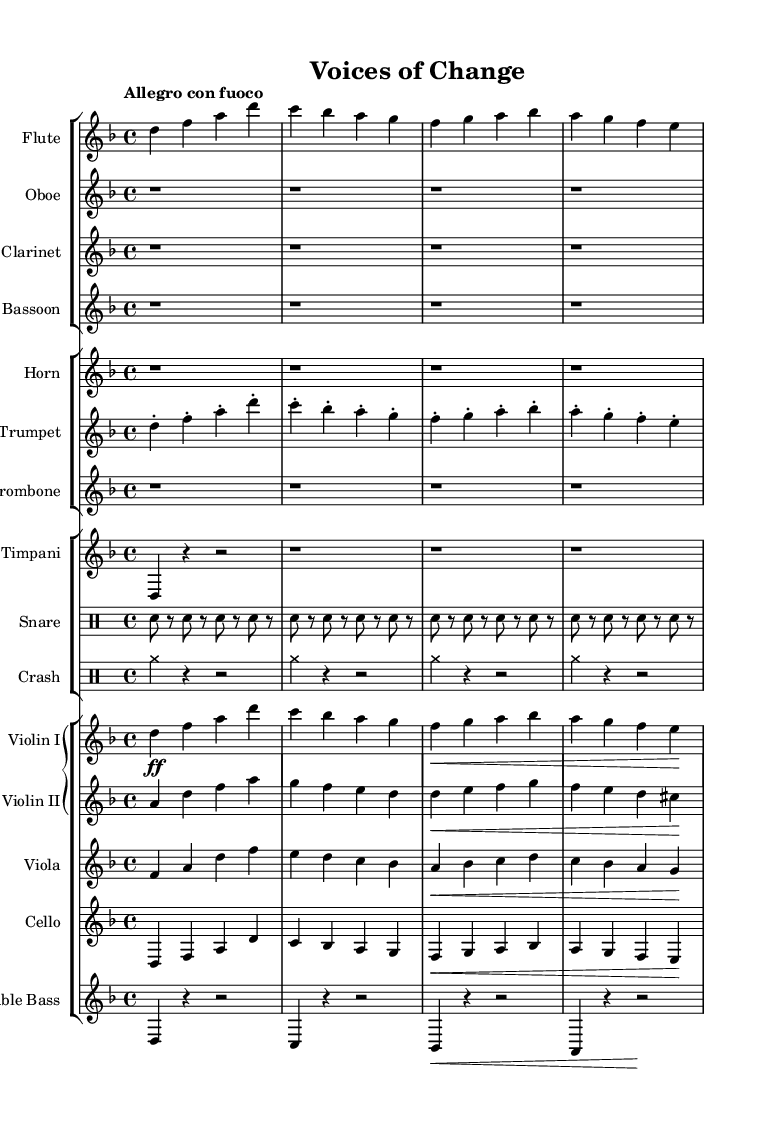What is the key signature of this music? The key signature is D minor, which has one flat (B♭).
Answer: D minor What is the time signature of the piece? The time signature is 4/4, indicating four beats per measure.
Answer: 4/4 What is the tempo marking for this composition? The tempo marking is "Allegro con fuoco", which suggests a fast and fiery pace.
Answer: Allegro con fuoco How many instruments are featured in this symphony? There are twelve individual parts, representing multiple instruments and sections in an orchestra.
Answer: Twelve What type of percussion instrument is used in this symphony? Timpani and snare drum are both present, contributing to the percussive aspect of the piece.
Answer: Timpani, snare drum Which two woodwind instruments are played without any notes in the provided measures? Oboe and clarinet have rests indicated throughout the measures.
Answer: Oboe, clarinet What dynamic marking is indicated for Violin I in the first measure? The dynamic marking is forte (ff), indicating a loud sound.
Answer: Forte 